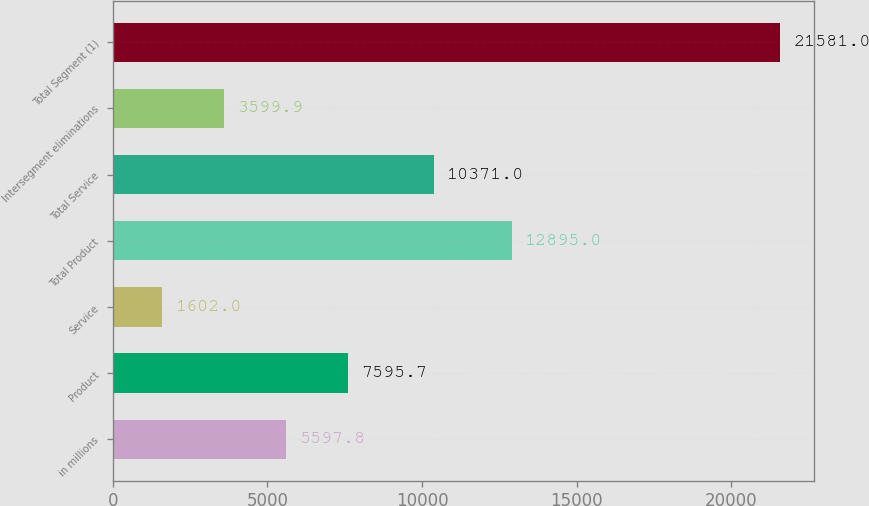Convert chart to OTSL. <chart><loc_0><loc_0><loc_500><loc_500><bar_chart><fcel>in millions<fcel>Product<fcel>Service<fcel>Total Product<fcel>Total Service<fcel>Intersegment eliminations<fcel>Total Segment (1)<nl><fcel>5597.8<fcel>7595.7<fcel>1602<fcel>12895<fcel>10371<fcel>3599.9<fcel>21581<nl></chart> 